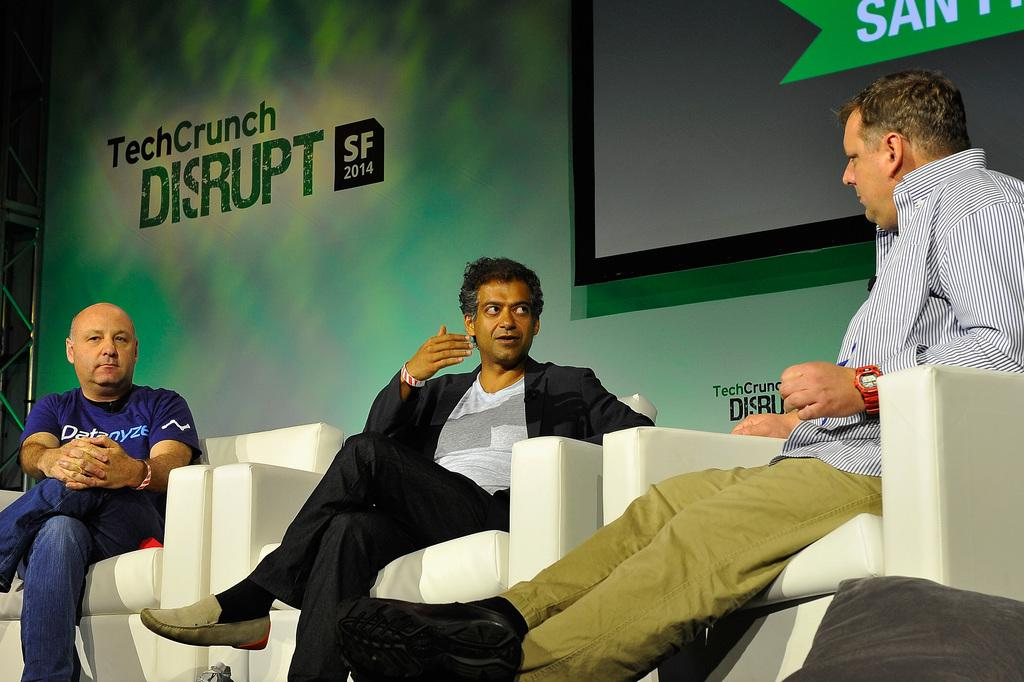How many people are in the image? There are three men in the image. What are the men doing in the image? The men are sitting on chairs. What can be seen in the background of the image? There is a metal frame in the image. What is written on the banner in the image? There is a banner with text in the image. What is the purpose of the display screen in the image? The display screen is present in the image, but its purpose cannot be determined without additional context. What type of plant is growing on the house in the image? There is no house or plant present in the image. What type of approval is required for the event depicted in the image? There is no event or indication of approval required in the image. 